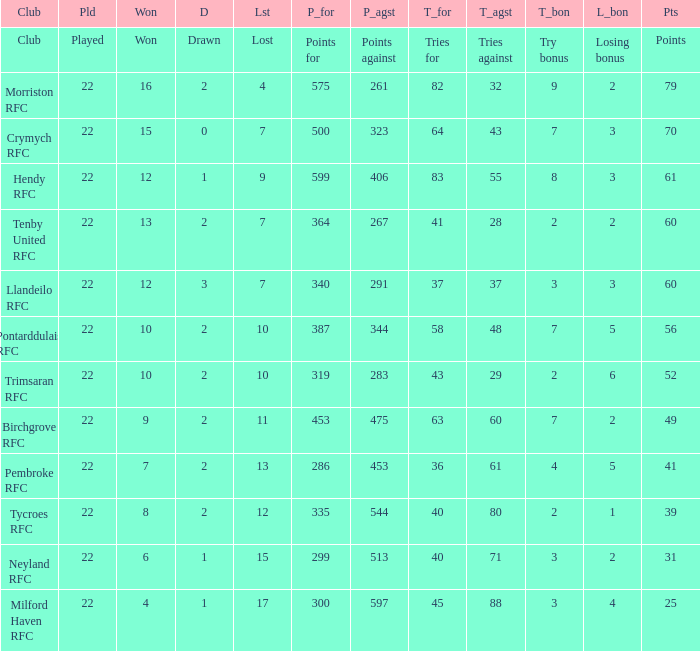What's the won with try bonus being 8 12.0. 